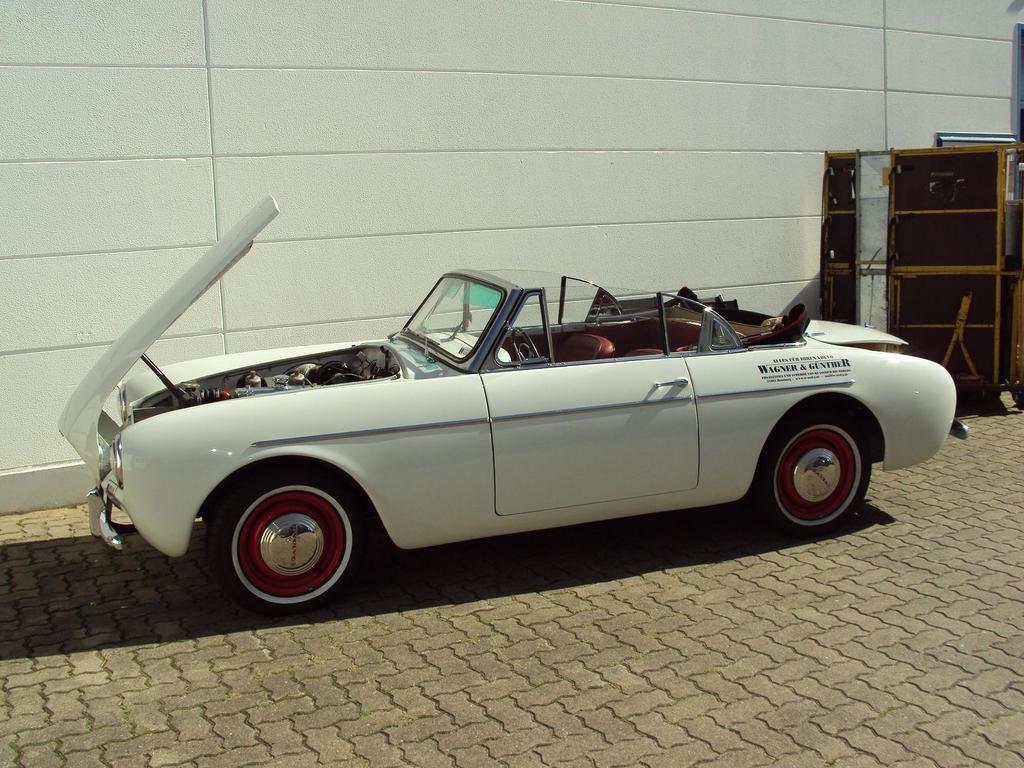Could you give a brief overview of what you see in this image? Here in this picture we can see a white colored car present on the ground over there and we can see its bonnet is opened and behind it we can see something present over there. 